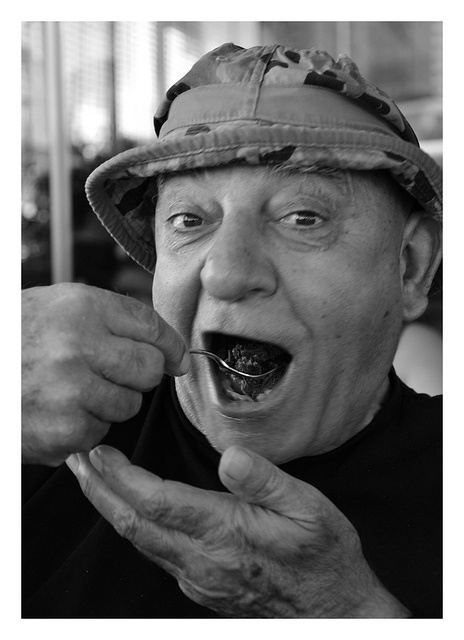Describe the objects in this image and their specific colors. I can see people in gray, white, black, darkgray, and lightgray tones, cake in black, gray, and white tones, and fork in white, black, gray, darkgray, and lightgray tones in this image. 